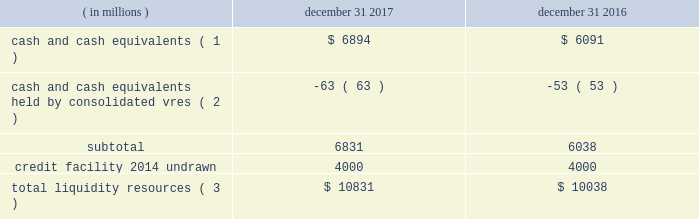Sources of blackrock 2019s operating cash primarily include investment advisory , administration fees and securities lending revenue , performance fees , revenue from technology and risk management services , advisory and other revenue and distribution fees .
Blackrock uses its cash to pay all operating expense , interest and principal on borrowings , income taxes , dividends on blackrock 2019s capital stock , repurchases of the company 2019s stock , capital expenditures and purchases of co-investments and seed investments .
For details of the company 2019s gaap cash flows from operating , investing and financing activities , see the consolidated statements of cash flows contained in part ii , item 8 of this filing .
Cash flows from operating activities , excluding the impact of consolidated sponsored investment funds , primarily include the receipt of investment advisory and administration fees , securities lending revenue and performance fees offset by the payment of operating expenses incurred in the normal course of business , including year-end incentive compensation accrued for in the prior year .
Cash outflows from investing activities , excluding the impact of consolidated sponsored investment funds , for 2017 were $ 517 million and primarily reflected $ 497 million of investment purchases , $ 155 million of purchases of property and equipment , $ 73 million related to the first reserve transaction and $ 29 million related to the cachematrix transaction , partially offset by $ 205 million of net proceeds from sales and maturities of certain investments .
Cash outflows from financing activities , excluding the impact of consolidated sponsored investment funds , for 2017 were $ 3094 million , primarily resulting from $ 1.4 billion of share repurchases , including $ 1.1 billion in open market- transactions and $ 321 million of employee tax withholdings related to employee stock transactions , $ 1.7 billion of cash dividend payments and $ 700 million of repayments of long- term borrowings , partially offset by $ 697 million of proceeds from issuance of long-term borrowings .
The company manages its financial condition and funding to maintain appropriate liquidity for the business .
Liquidity resources at december 31 , 2017 and 2016 were as follows : ( in millions ) december 31 , december 31 , cash and cash equivalents ( 1 ) $ 6894 $ 6091 cash and cash equivalents held by consolidated vres ( 2 ) ( 63 ) ( 53 ) .
Total liquidity resources ( 3 ) $ 10831 $ 10038 ( 1 ) the percentage of cash and cash equivalents held by the company 2019s u.s .
Subsidiaries was approximately 40% ( 40 % ) and 50% ( 50 % ) at december 31 , 2017 and 2016 , respectively .
See net capital requirements herein for more information on net capital requirements in certain regulated subsidiaries .
( 2 ) the company cannot readily access such cash to use in its operating activities .
( 3 ) amounts do not reflect a reduction for year-end incentive compensation accruals of approximately $ 1.5 billion and $ 1.3 billion for 2017 and 2016 , respectively , which are paid in the first quarter of the following year .
Total liquidity resources increased $ 793 million during 2017 , primarily reflecting cash flows from operating activities , partially offset by cash payments of 2016 year-end incentive awards , share repurchases of $ 1.4 billion and cash dividend payments of $ 1.7 billion .
A significant portion of the company 2019s $ 3154 million of total investments , as adjusted , is illiquid in nature and , as such , cannot be readily convertible to cash .
Share repurchases .
The company repurchased 2.6 million common shares in open market transactions under the share repurchase program for approximately $ 1.1 billion during 2017 .
At december 31 , 2017 , there were 6.4 million shares still authorized to be repurchased .
Net capital requirements .
The company is required to maintain net capital in certain regulated subsidiaries within a number of jurisdictions , which is partially maintained by retaining cash and cash equivalent investments in those subsidiaries or jurisdictions .
As a result , such subsidiaries of the company may be restricted in their ability to transfer cash between different jurisdictions and to their parents .
Additionally , transfers of cash between international jurisdictions may have adverse tax consequences that could discourage such transfers .
Blackrock institutional trust company , n.a .
( 201cbtc 201d ) is chartered as a national bank that does not accept client deposits and whose powers are limited to trust and other fiduciary activities .
Btc provides investment management services , including investment advisory and securities lending agency services , to institutional clients .
Btc is subject to regulatory capital and liquid asset requirements administered by the office of the comptroller of the currency .
At december 31 , 2017 and 2016 , the company was required to maintain approximately $ 1.8 billion and $ 1.4 billion , respectively , in net capital in certain regulated subsidiaries , including btc , entities regulated by the financial conduct authority and prudential regulation authority in the united kingdom , and the company 2019s broker-dealers .
The company was in compliance with all applicable regulatory net capital requirements .
Undistributed earnings of foreign subsidiaries .
As a result of the 2017 tax act and the one-time mandatory deemed repatriation tax on untaxed accumulated foreign earnings , a provisional amount of u.s .
Income taxes was provided on the undistributed foreign earnings .
The financial statement basis in excess of tax basis of its foreign subsidiaries remains indefinitely reinvested in foreign operations .
The company will continue to evaluate its capital management plans throughout 2018 .
Short-term borrowings 2017 revolving credit facility .
The company 2019s credit facility has an aggregate commitment amount of $ 4.0 billion and was amended in april 2017 to extend the maturity date to april 2022 ( the 201c2017 credit facility 201d ) .
The 2017 credit facility permits the company to request up to an additional $ 1.0 billion of borrowing capacity , subject to lender credit approval , increasing the overall size of the 2017 credit facility to an aggregate principal amount not to exceed $ 5.0 billion .
Interest on borrowings outstanding accrues at a rate based on the applicable london interbank offered rate plus a spread .
The 2017 credit facility requires the company .
What is the growth rate in the balance of cash and cash equivalents in 2017? 
Computations: ((6894 - 6091) / 6091)
Answer: 0.13183. 